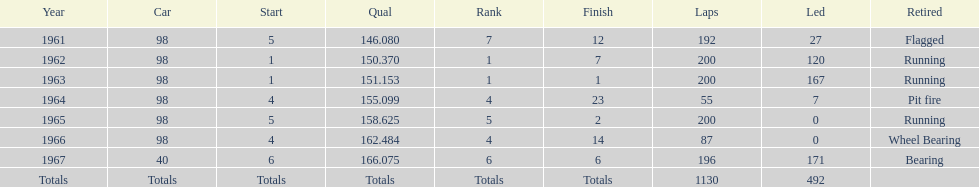What is the cumulative number of laps completed in the indy 500? 1130. 